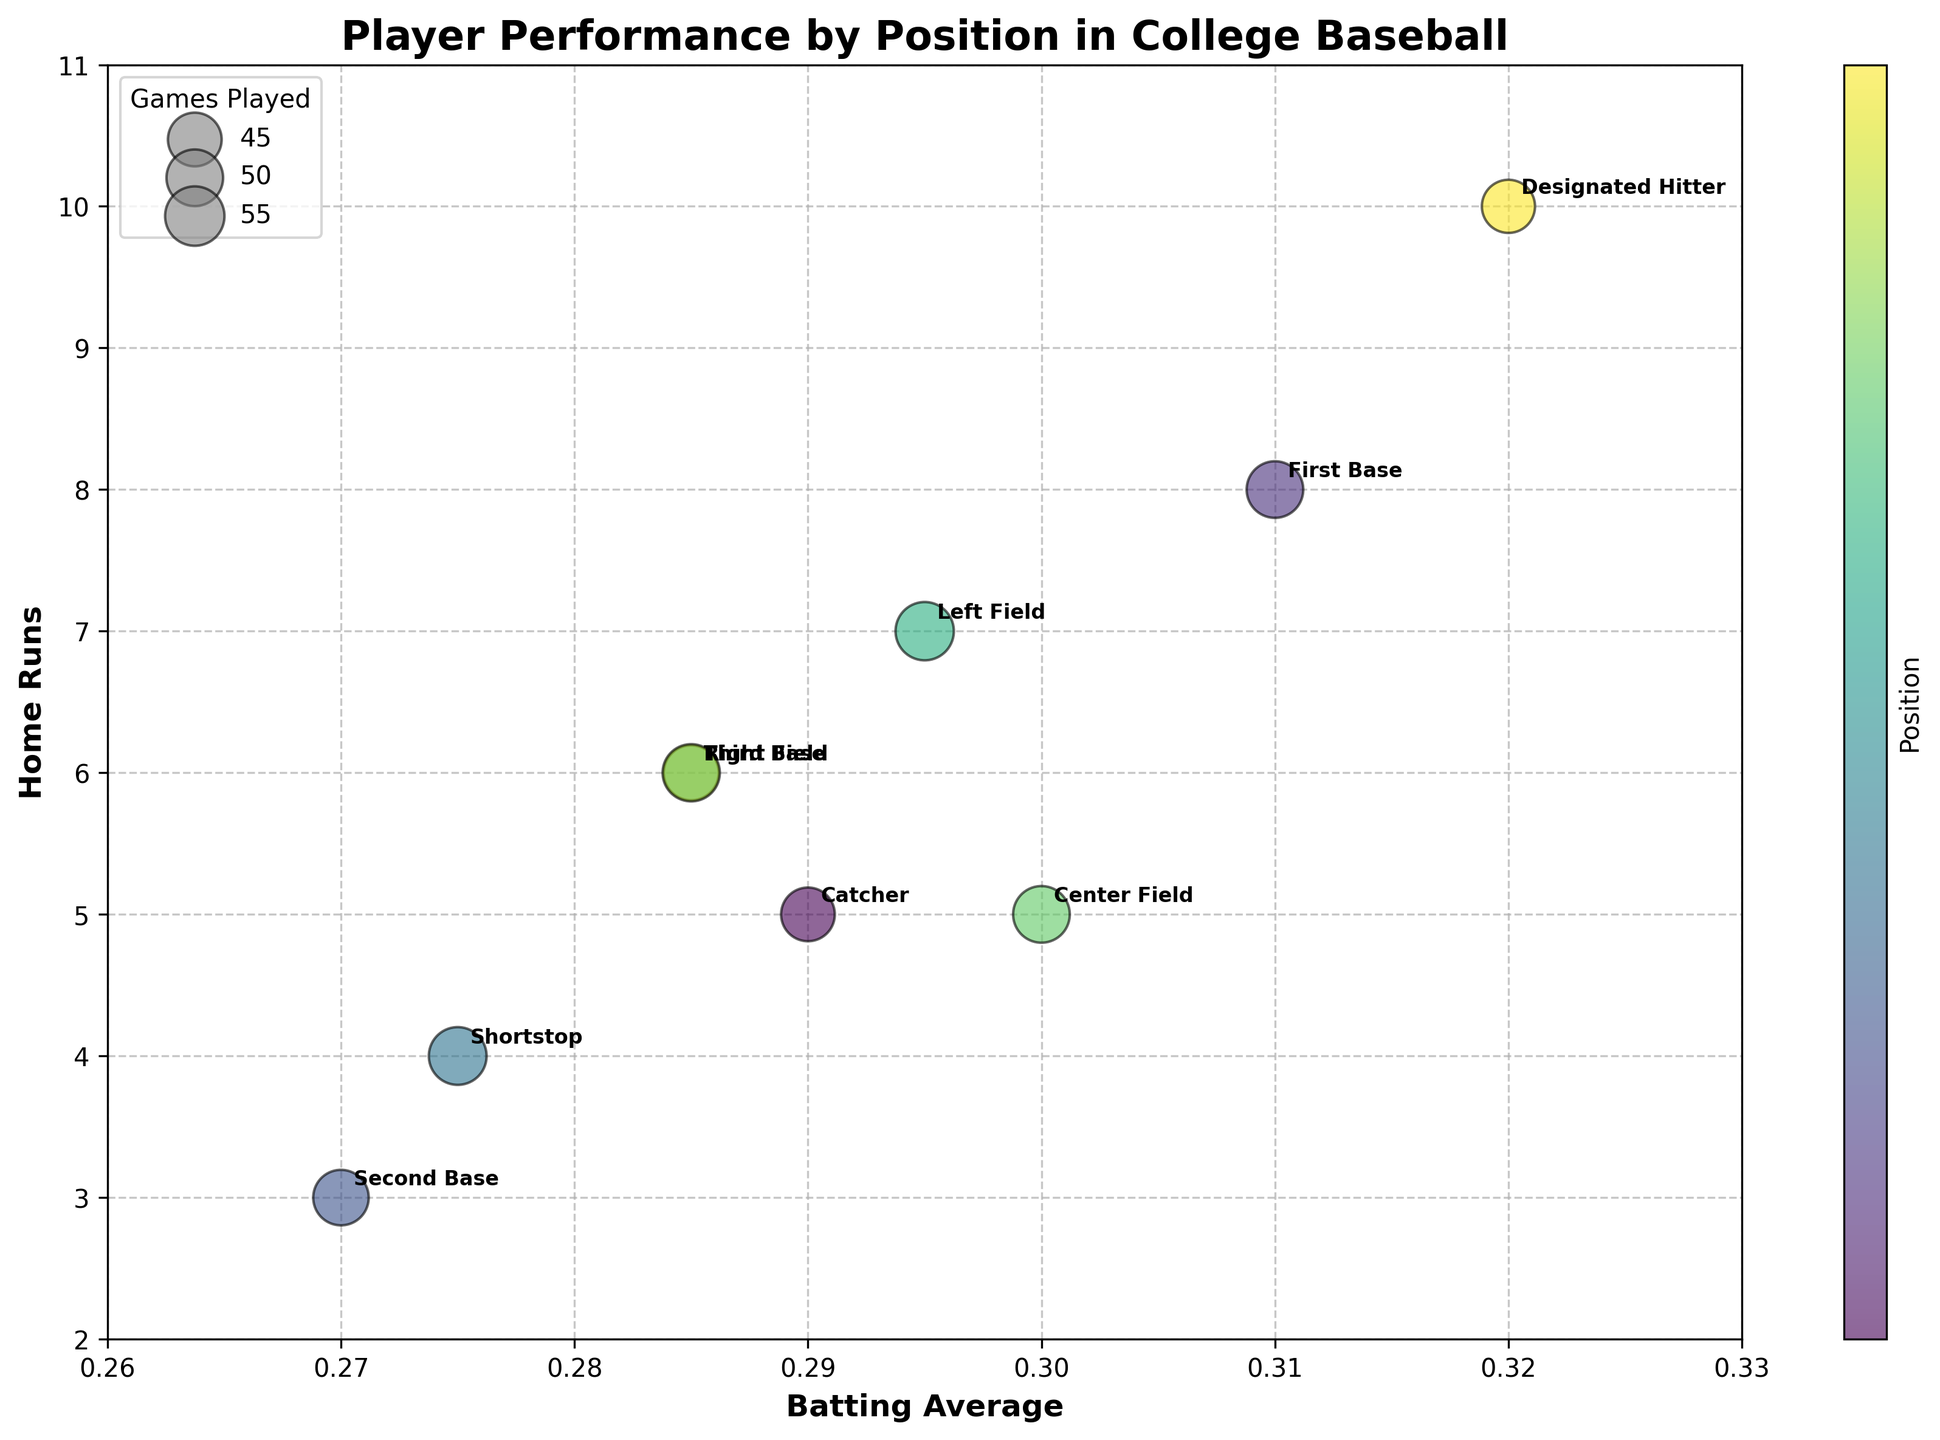What is the title of the chart? The title is typically displayed at the top of the chart. In this case, the figure's title is clearly stated in large, bold text.
Answer: Player Performance by Position in College Baseball Which player has the highest batting average? Look at the x-axis (Batting Average) and identify the player represented by the bubble furthest to the right. In this case, it is the bubble labeled "Jason Taylor."
Answer: Jason Taylor What is the home run count for the player with the lowest batting average? Find the bubble closest to the left on the x-axis and check its corresponding y-axis value (Home Runs). The position is "Michael Reyes," who has 3 home runs.
Answer: 3 Which position has the most games played? Larger bubbles indicate more games played. Find the biggest bubble and check its label. "Brian O'Connor" (Left Field) plays 53 games, the largest bubble in the chart.
Answer: Left Field Between the players at Right Field and Third Base, who has more home runs? Compare the y-axis values of the bubbles labeled "Andrew Collins" (Right Field) and "Josh Thompson" (Third Base). Both are at the same y-axis value (6), so they have equal home runs.
Answer: Both have the same What is the total number of home runs hit by players in infield positions? Calculate the sum of home runs for Catcher, First Base, Second Base, Shortstop, and Third Base. 5 (Brad Johnson) + 8 (David Lee) + 3 (Michael Reyes) + 4 (Chris Martinez) + 6 (Josh Thompson) = 26.
Answer: 26 Which position has a higher number of games played: Center Field or Catcher? Look at the size of the bubbles for "Kevin Smith" (Center Field) and "Brad Johnson" (Catcher). The Center Field bubble is larger (50 vs. 45).
Answer: Center Field What is the average home runs for players with a batting average above 0.3? Identify players with a batting average above 0.3 and then calculate the average home runs. "David Lee" (8) + "Kevin Smith" (5) + "Jason Taylor" (10) = 23/3 = 7.67.
Answer: 7.67 Which two positions have the closest batting averages? Look for bubbles closest to each other along the x-axis (Batting Average). "Right Field" (Andrew Collins) and "Third Base" (Josh Thompson) both are at 0.285.
Answer: Right Field and Third Base What is the range of home runs hit by the outfield positions? Identify the y-axis (Home Runs) values for outfield positions (Left Field, Center Field, Right Field). Min is 5 (Kevin Smith), and max is 7 (Brian O'Connor). The range is 7 - 5 = 2.
Answer: 2 